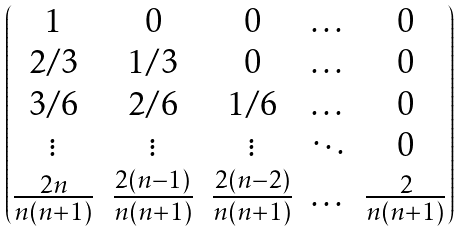<formula> <loc_0><loc_0><loc_500><loc_500>\begin{pmatrix} 1 & 0 & 0 & \dots & 0 \\ 2 / 3 & 1 / 3 & 0 & \dots & 0 \\ 3 / 6 & 2 / 6 & 1 / 6 & \dots & 0 \\ \vdots & \vdots & \vdots & \ddots & 0 \\ \frac { 2 n } { n ( n + 1 ) } & \frac { 2 ( n - 1 ) } { n ( n + 1 ) } & \frac { 2 ( n - 2 ) } { n ( n + 1 ) } & \dots & \frac { 2 } { n ( n + 1 ) } \end{pmatrix}</formula> 